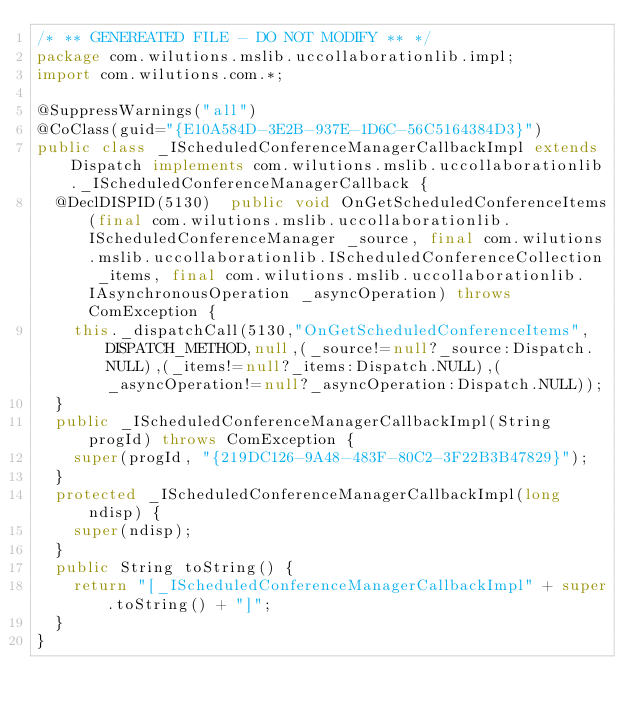<code> <loc_0><loc_0><loc_500><loc_500><_Java_>/* ** GENEREATED FILE - DO NOT MODIFY ** */
package com.wilutions.mslib.uccollaborationlib.impl;
import com.wilutions.com.*;

@SuppressWarnings("all")
@CoClass(guid="{E10A584D-3E2B-937E-1D6C-56C5164384D3}")
public class _IScheduledConferenceManagerCallbackImpl extends Dispatch implements com.wilutions.mslib.uccollaborationlib._IScheduledConferenceManagerCallback {
  @DeclDISPID(5130)  public void OnGetScheduledConferenceItems(final com.wilutions.mslib.uccollaborationlib.IScheduledConferenceManager _source, final com.wilutions.mslib.uccollaborationlib.IScheduledConferenceCollection _items, final com.wilutions.mslib.uccollaborationlib.IAsynchronousOperation _asyncOperation) throws ComException {
    this._dispatchCall(5130,"OnGetScheduledConferenceItems", DISPATCH_METHOD,null,(_source!=null?_source:Dispatch.NULL),(_items!=null?_items:Dispatch.NULL),(_asyncOperation!=null?_asyncOperation:Dispatch.NULL));
  }
  public _IScheduledConferenceManagerCallbackImpl(String progId) throws ComException {
    super(progId, "{219DC126-9A48-483F-80C2-3F22B3B47829}");
  }
  protected _IScheduledConferenceManagerCallbackImpl(long ndisp) {
    super(ndisp);
  }
  public String toString() {
    return "[_IScheduledConferenceManagerCallbackImpl" + super.toString() + "]";
  }
}
</code> 